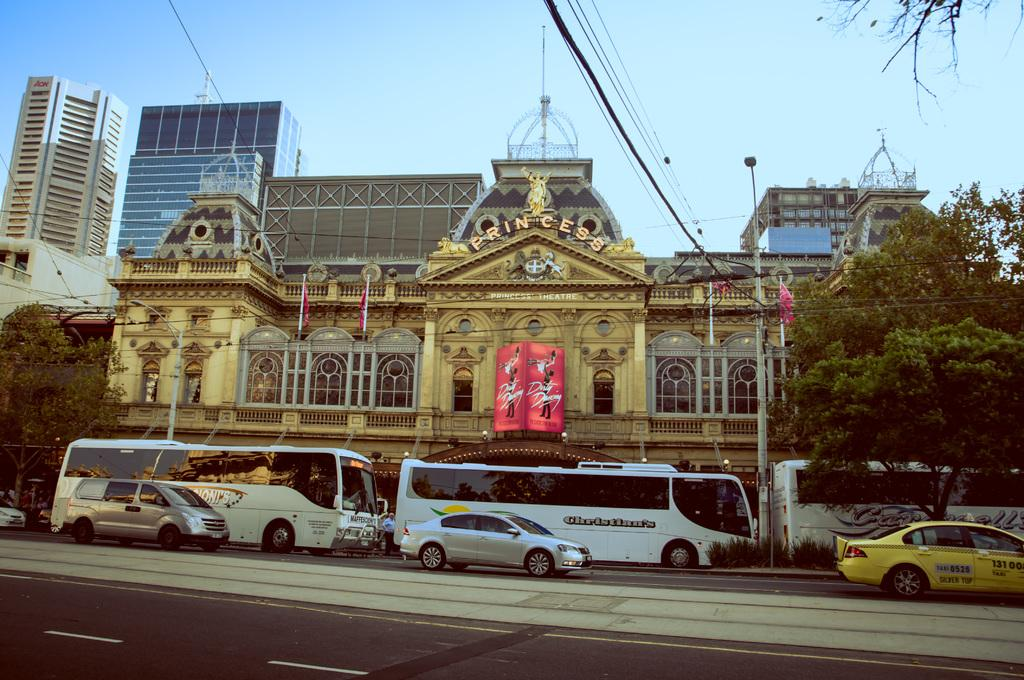Provide a one-sentence caption for the provided image. Three white buses sit outside of the Princess Building. 